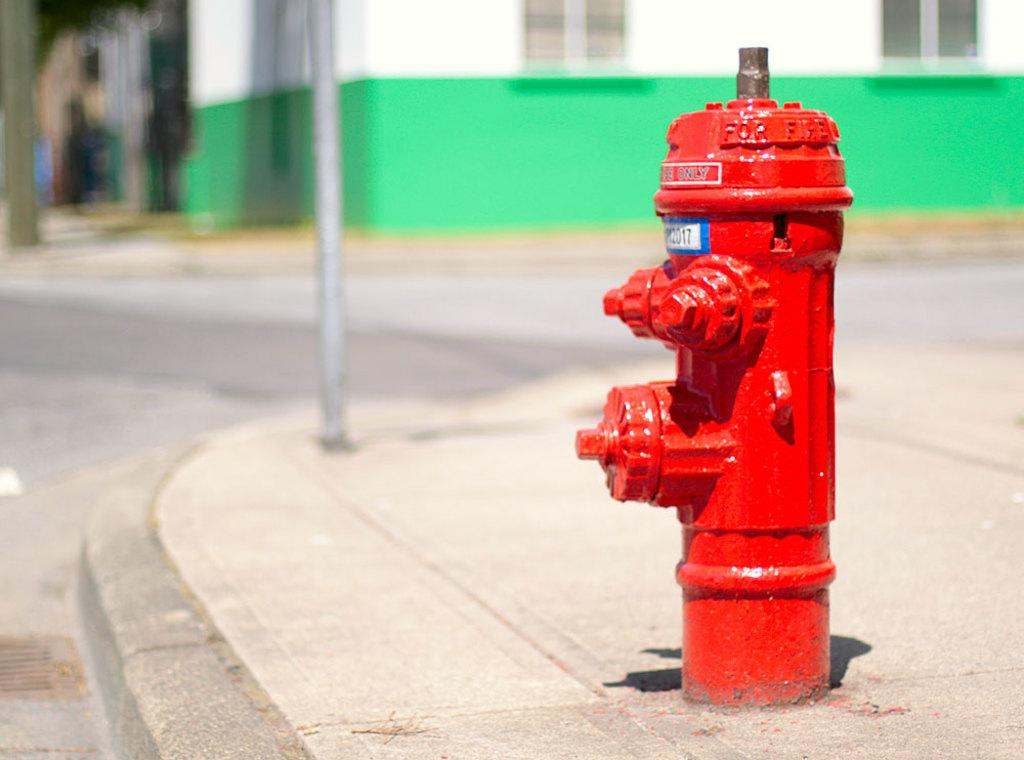What is the color of the water hydrant in the image? The water hydrant in the image is red. What can be seen in the background of the image? There is a pole and a house in the background of the image. What type of engine is powering the dinosaurs in the image? There are no dinosaurs or engines present in the image. 